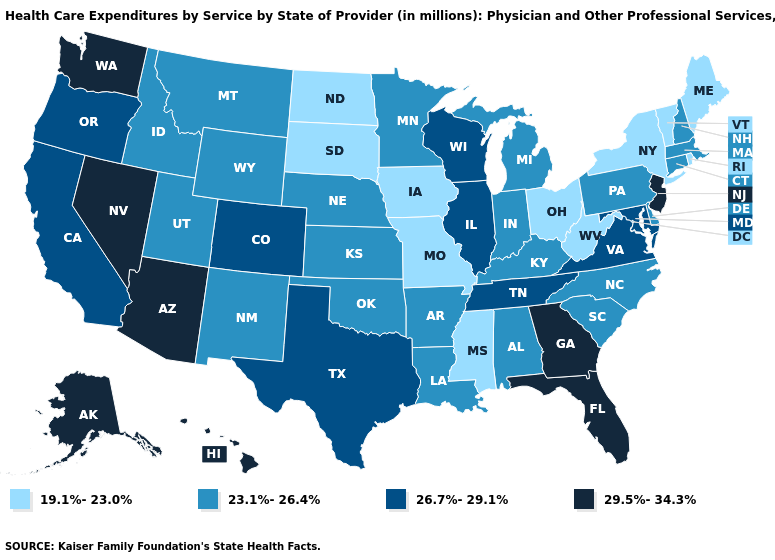What is the highest value in states that border California?
Write a very short answer. 29.5%-34.3%. How many symbols are there in the legend?
Quick response, please. 4. Among the states that border Louisiana , does Arkansas have the lowest value?
Be succinct. No. Among the states that border Georgia , which have the highest value?
Be succinct. Florida. Does Georgia have the highest value in the South?
Concise answer only. Yes. Which states have the lowest value in the MidWest?
Quick response, please. Iowa, Missouri, North Dakota, Ohio, South Dakota. What is the value of North Carolina?
Short answer required. 23.1%-26.4%. Does Virginia have the lowest value in the USA?
Quick response, please. No. Among the states that border Kentucky , does Ohio have the lowest value?
Concise answer only. Yes. What is the lowest value in the South?
Answer briefly. 19.1%-23.0%. Name the states that have a value in the range 29.5%-34.3%?
Answer briefly. Alaska, Arizona, Florida, Georgia, Hawaii, Nevada, New Jersey, Washington. What is the highest value in the South ?
Concise answer only. 29.5%-34.3%. Name the states that have a value in the range 29.5%-34.3%?
Be succinct. Alaska, Arizona, Florida, Georgia, Hawaii, Nevada, New Jersey, Washington. Among the states that border Montana , which have the lowest value?
Quick response, please. North Dakota, South Dakota. Does the first symbol in the legend represent the smallest category?
Give a very brief answer. Yes. 